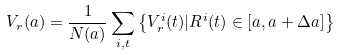<formula> <loc_0><loc_0><loc_500><loc_500>V _ { r } ( a ) = \frac { 1 } { N ( a ) } \sum _ { i , t } \left \{ V _ { r } ^ { i } ( t ) | R ^ { i } ( t ) \in [ a , a + \Delta a ] \right \}</formula> 